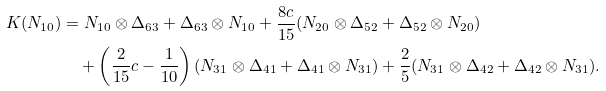<formula> <loc_0><loc_0><loc_500><loc_500>K ( N _ { 1 0 } ) & = N _ { 1 0 } \otimes \Delta _ { 6 3 } + \Delta _ { 6 3 } \otimes N _ { 1 0 } + \frac { 8 c } { 1 5 } ( N _ { 2 0 } \otimes \Delta _ { 5 2 } + \Delta _ { 5 2 } \otimes N _ { 2 0 } ) \\ & \quad + \left ( \frac { 2 } { 1 5 } c - \frac { 1 } { 1 0 } \right ) ( N _ { 3 1 } \otimes \Delta _ { 4 1 } + \Delta _ { 4 1 } \otimes N _ { 3 1 } ) + \frac { 2 } { 5 } ( N _ { 3 1 } \otimes \Delta _ { 4 2 } + \Delta _ { 4 2 } \otimes N _ { 3 1 } ) .</formula> 